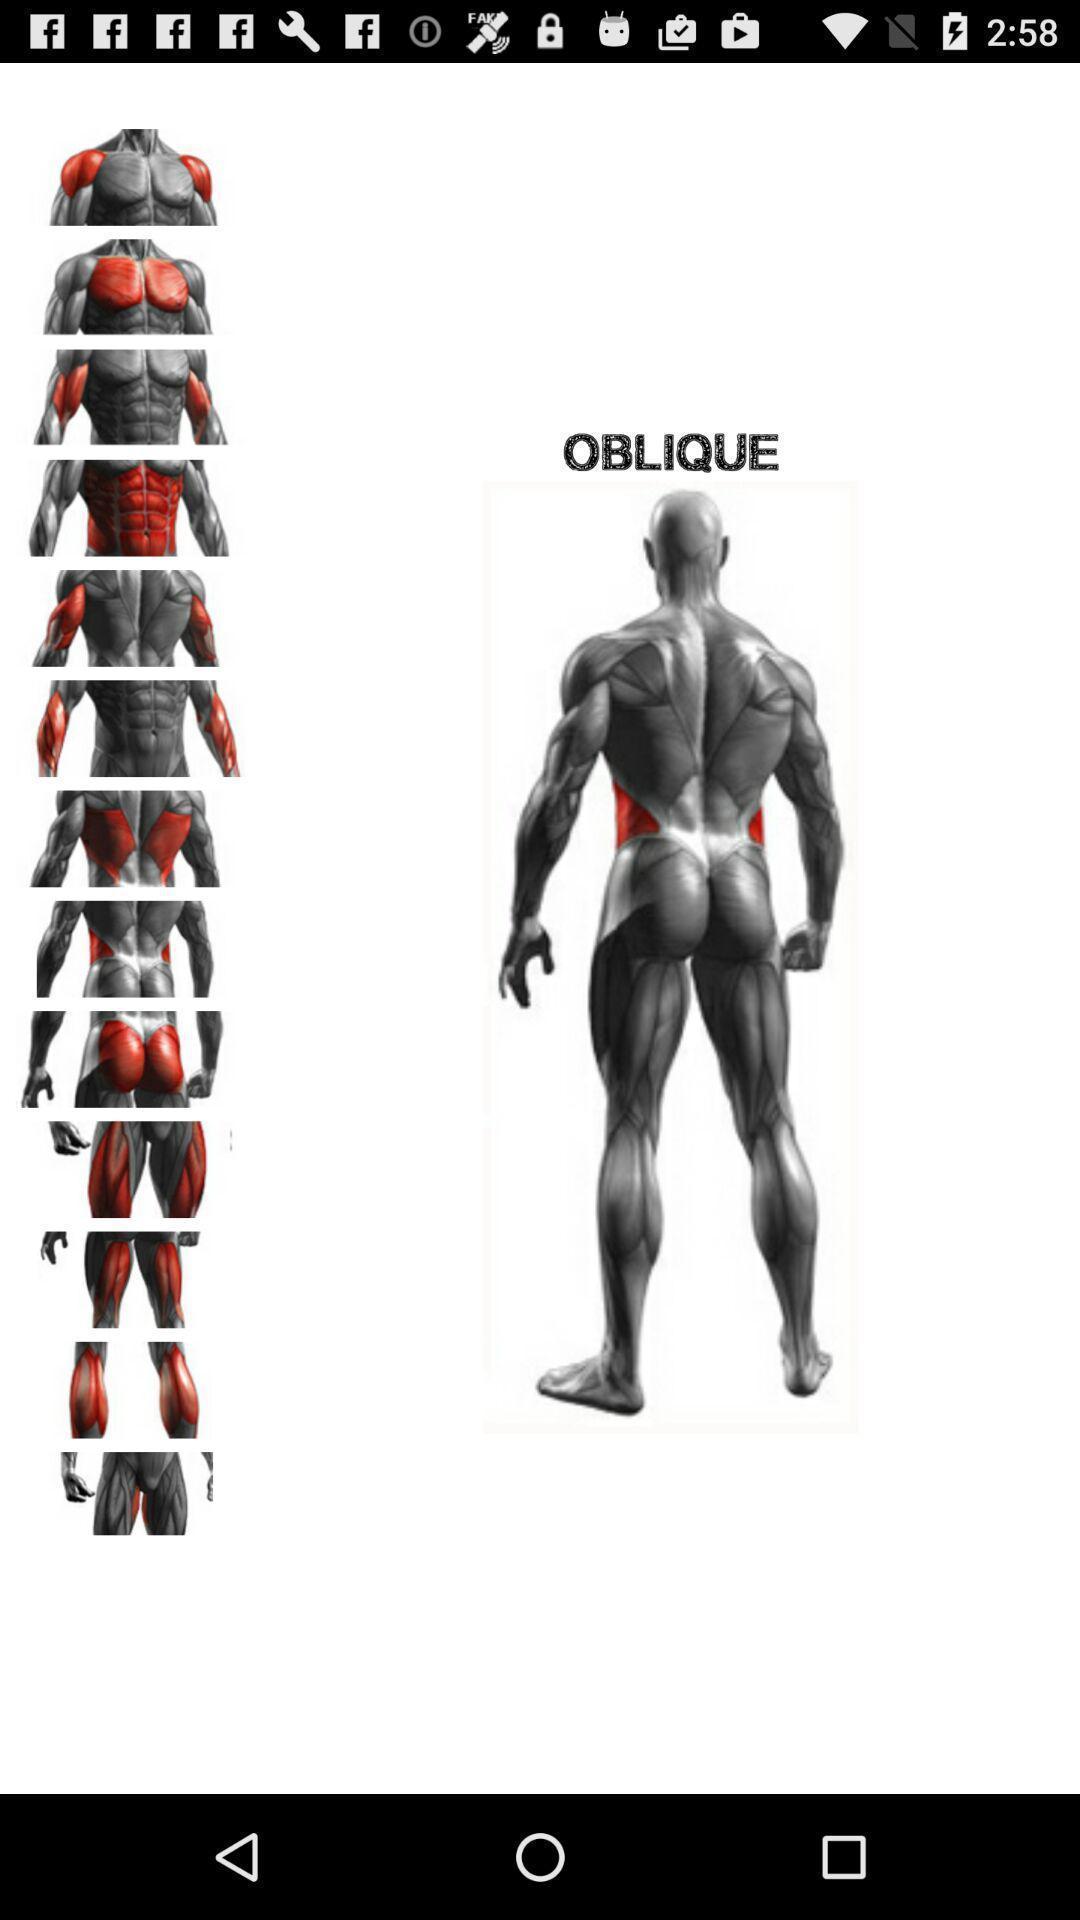Please provide a description for this image. Screen showing page. 